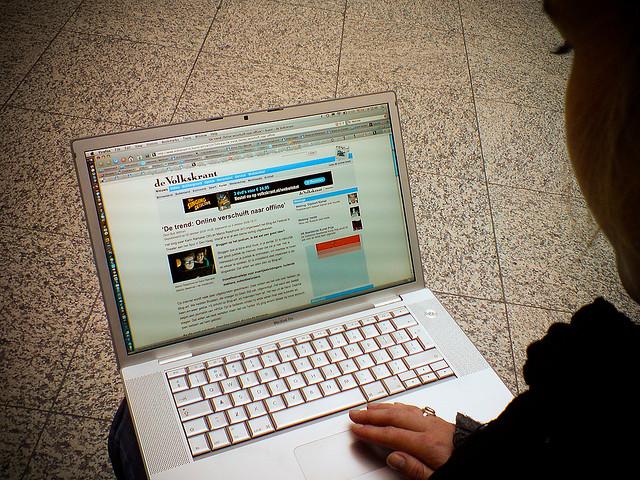What color is the laptop?
Short answer required. Silver. Is the laptop big or small?
Be succinct. Small. What brand of laptop is that?
Answer briefly. Apple. How many windows are open on the monitor?
Give a very brief answer. 1. Is that a full keyboard under her monitor?
Keep it brief. Yes. 